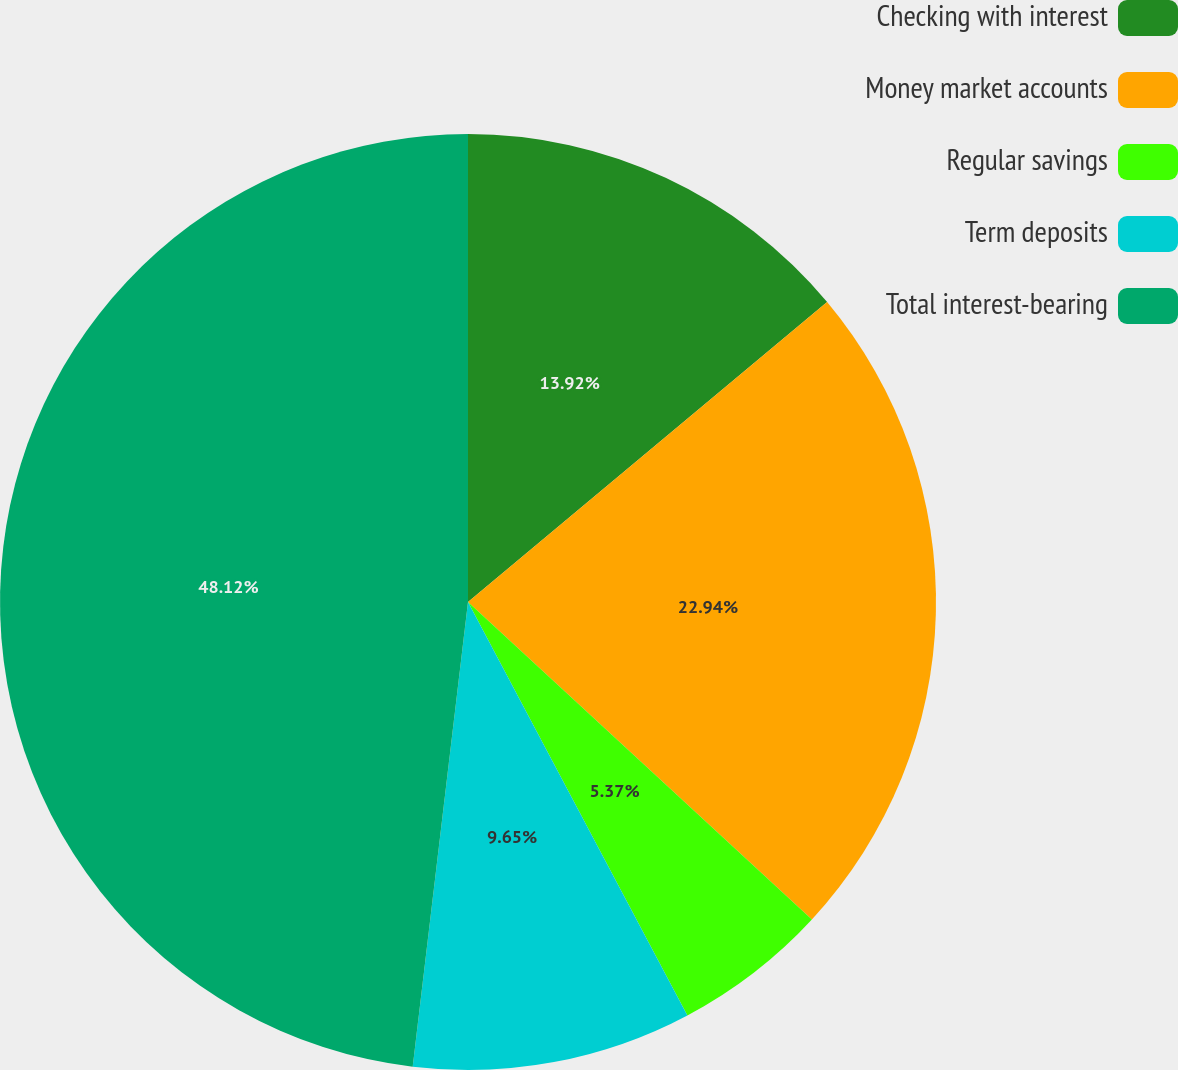Convert chart. <chart><loc_0><loc_0><loc_500><loc_500><pie_chart><fcel>Checking with interest<fcel>Money market accounts<fcel>Regular savings<fcel>Term deposits<fcel>Total interest-bearing<nl><fcel>13.92%<fcel>22.94%<fcel>5.37%<fcel>9.65%<fcel>48.11%<nl></chart> 